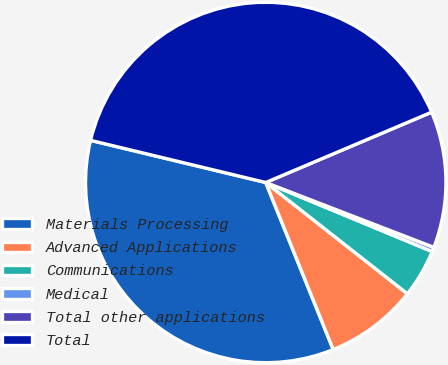Convert chart to OTSL. <chart><loc_0><loc_0><loc_500><loc_500><pie_chart><fcel>Materials Processing<fcel>Advanced Applications<fcel>Communications<fcel>Medical<fcel>Total other applications<fcel>Total<nl><fcel>34.87%<fcel>8.29%<fcel>4.34%<fcel>0.4%<fcel>12.24%<fcel>39.86%<nl></chart> 